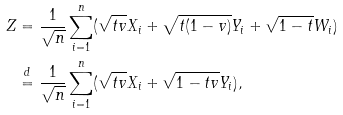<formula> <loc_0><loc_0><loc_500><loc_500>Z & = \frac { 1 } { \sqrt { n } } \sum _ { i = 1 } ^ { n } ( \sqrt { t v } X _ { i } + \sqrt { t ( 1 - v ) } Y _ { i } + \sqrt { 1 - t } W _ { i } ) \\ & \stackrel { d } { = } \frac { 1 } { \sqrt { n } } \sum _ { i = 1 } ^ { n } ( \sqrt { t v } X _ { i } + \sqrt { 1 - t v } Y _ { i } ) ,</formula> 